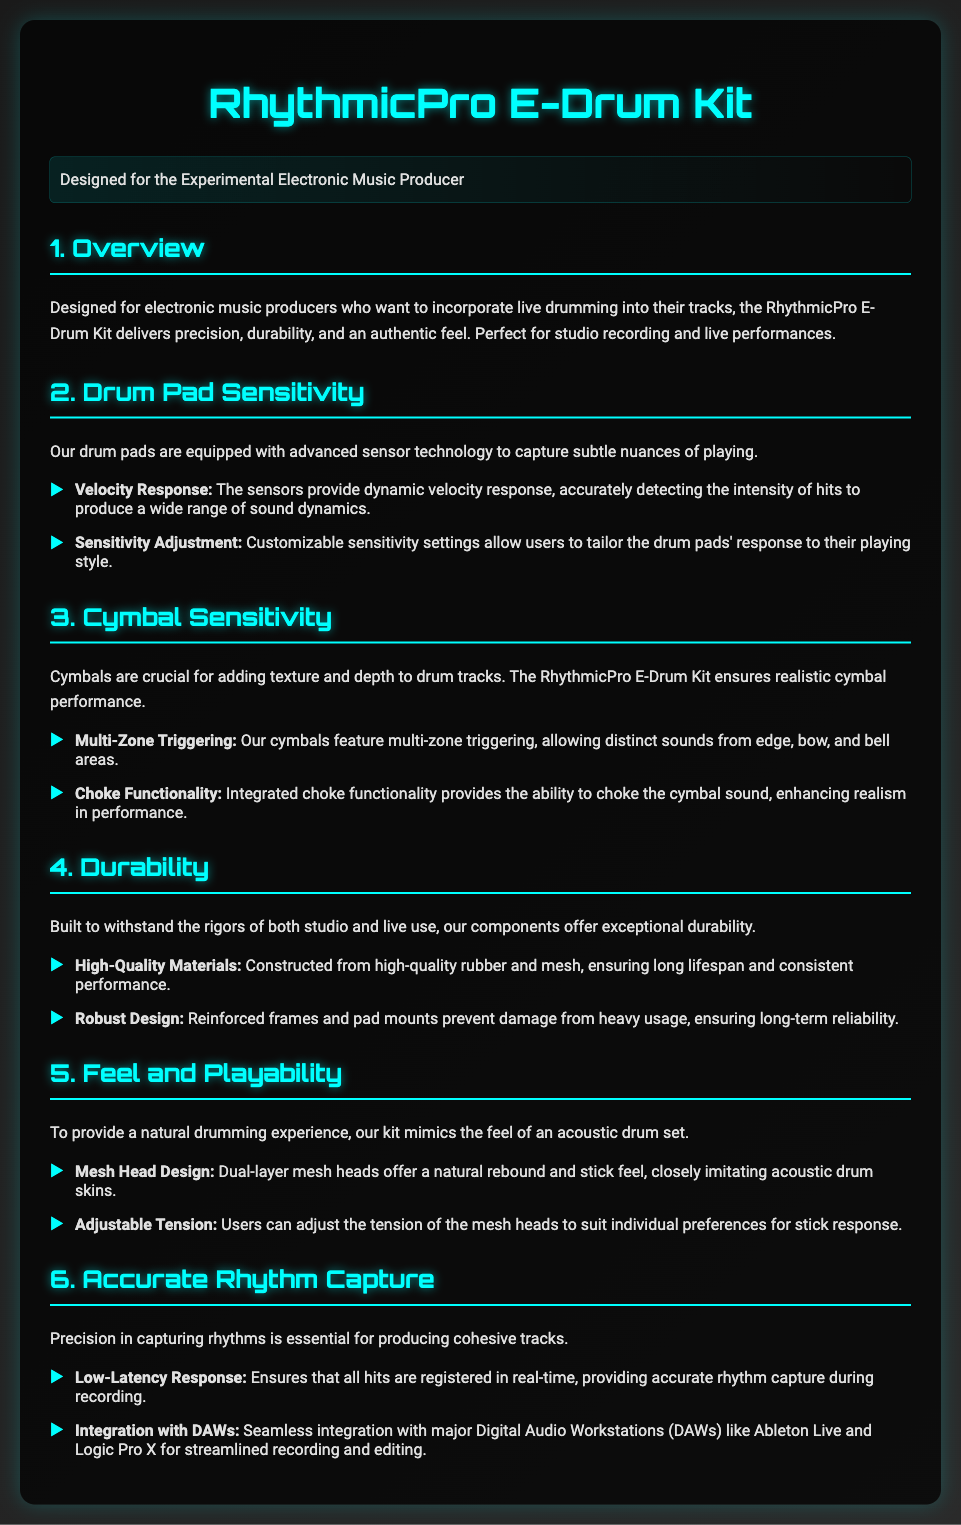what is the name of the product? The product name is stated in the title of the document.
Answer: RhythmicPro E-Drum Kit who is the target audience for the E-Drum Kit? The target audience is specified in the overview section of the document.
Answer: Experimental Electronic Music Producer what kind of materials are used for construction? The document lists the materials used in the durability section.
Answer: High-quality rubber and mesh what feature allows distinct sounds from different areas of the cymbals? This feature is mentioned in the cymbal sensitivity section.
Answer: Multi-Zone Triggering how many layers do the mesh heads have? The mesh head design details the number of layers.
Answer: Dual-layer what functionality allows a user to stop the cymbal sound? The functionality is explicitly mentioned in the cymbal sensitivity details.
Answer: Choke Functionality what is the purpose of sensitivity adjustment? The purpose of sensitivity adjustment is explained in the drum pad sensitivity section.
Answer: Tailor the drum pads' response to playing style how does the kit ensure accurate rhythm capture? The method for capturing accurate rhythms is described in the relevant section.
Answer: Low-Latency Response which DAWs are mentioned for integration? The document provides details about the DAWs in the rhythm capture section.
Answer: Ableton Live and Logic Pro X 